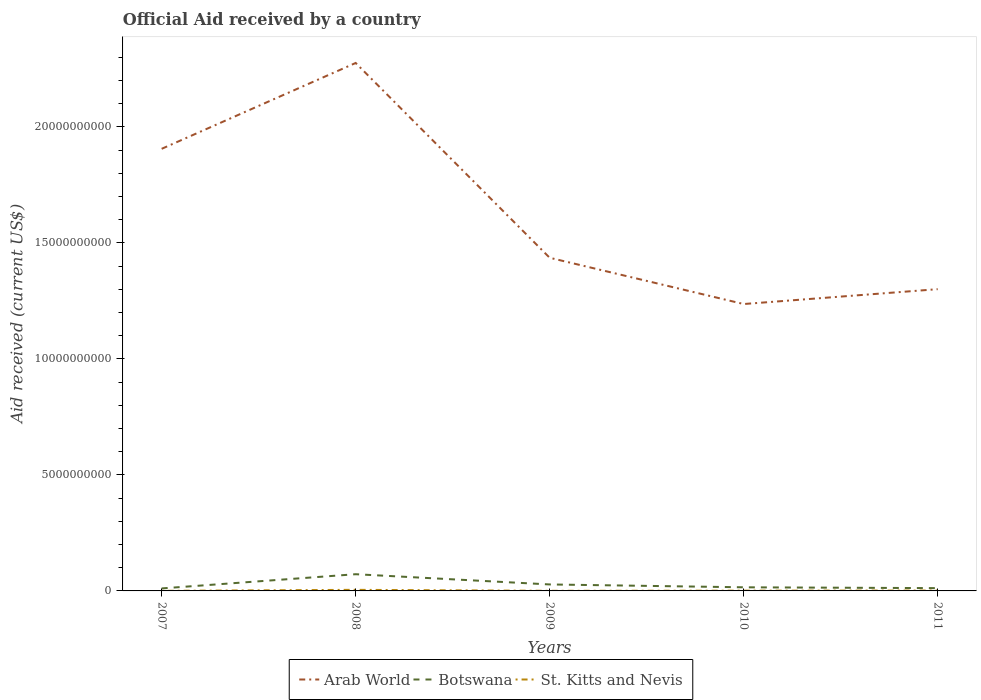How many different coloured lines are there?
Ensure brevity in your answer.  3. Does the line corresponding to St. Kitts and Nevis intersect with the line corresponding to Arab World?
Your answer should be very brief. No. Across all years, what is the maximum net official aid received in St. Kitts and Nevis?
Ensure brevity in your answer.  3.44e+06. What is the total net official aid received in Arab World in the graph?
Ensure brevity in your answer.  1.04e+1. What is the difference between the highest and the second highest net official aid received in Botswana?
Offer a very short reply. 6.13e+08. What is the difference between the highest and the lowest net official aid received in Arab World?
Make the answer very short. 2. How many lines are there?
Your response must be concise. 3. How many years are there in the graph?
Your answer should be compact. 5. Does the graph contain any zero values?
Offer a very short reply. No. How many legend labels are there?
Provide a succinct answer. 3. What is the title of the graph?
Make the answer very short. Official Aid received by a country. What is the label or title of the X-axis?
Keep it short and to the point. Years. What is the label or title of the Y-axis?
Keep it short and to the point. Aid received (current US$). What is the Aid received (current US$) in Arab World in 2007?
Your answer should be very brief. 1.91e+1. What is the Aid received (current US$) in Botswana in 2007?
Offer a very short reply. 1.08e+08. What is the Aid received (current US$) in St. Kitts and Nevis in 2007?
Provide a short and direct response. 3.44e+06. What is the Aid received (current US$) of Arab World in 2008?
Offer a terse response. 2.28e+1. What is the Aid received (current US$) of Botswana in 2008?
Your answer should be very brief. 7.20e+08. What is the Aid received (current US$) of St. Kitts and Nevis in 2008?
Your response must be concise. 4.68e+07. What is the Aid received (current US$) of Arab World in 2009?
Provide a short and direct response. 1.44e+1. What is the Aid received (current US$) in Botswana in 2009?
Your answer should be very brief. 2.79e+08. What is the Aid received (current US$) of St. Kitts and Nevis in 2009?
Make the answer very short. 5.13e+06. What is the Aid received (current US$) of Arab World in 2010?
Keep it short and to the point. 1.24e+1. What is the Aid received (current US$) in Botswana in 2010?
Give a very brief answer. 1.56e+08. What is the Aid received (current US$) in St. Kitts and Nevis in 2010?
Provide a short and direct response. 1.14e+07. What is the Aid received (current US$) in Arab World in 2011?
Offer a very short reply. 1.30e+1. What is the Aid received (current US$) of Botswana in 2011?
Make the answer very short. 1.20e+08. What is the Aid received (current US$) in St. Kitts and Nevis in 2011?
Offer a very short reply. 1.60e+07. Across all years, what is the maximum Aid received (current US$) of Arab World?
Provide a short and direct response. 2.28e+1. Across all years, what is the maximum Aid received (current US$) of Botswana?
Your answer should be compact. 7.20e+08. Across all years, what is the maximum Aid received (current US$) of St. Kitts and Nevis?
Your answer should be very brief. 4.68e+07. Across all years, what is the minimum Aid received (current US$) in Arab World?
Provide a short and direct response. 1.24e+1. Across all years, what is the minimum Aid received (current US$) in Botswana?
Provide a succinct answer. 1.08e+08. Across all years, what is the minimum Aid received (current US$) in St. Kitts and Nevis?
Make the answer very short. 3.44e+06. What is the total Aid received (current US$) of Arab World in the graph?
Give a very brief answer. 8.16e+1. What is the total Aid received (current US$) of Botswana in the graph?
Make the answer very short. 1.38e+09. What is the total Aid received (current US$) in St. Kitts and Nevis in the graph?
Keep it short and to the point. 8.28e+07. What is the difference between the Aid received (current US$) of Arab World in 2007 and that in 2008?
Offer a terse response. -3.70e+09. What is the difference between the Aid received (current US$) of Botswana in 2007 and that in 2008?
Offer a very short reply. -6.13e+08. What is the difference between the Aid received (current US$) in St. Kitts and Nevis in 2007 and that in 2008?
Keep it short and to the point. -4.34e+07. What is the difference between the Aid received (current US$) in Arab World in 2007 and that in 2009?
Provide a short and direct response. 4.70e+09. What is the difference between the Aid received (current US$) in Botswana in 2007 and that in 2009?
Offer a terse response. -1.71e+08. What is the difference between the Aid received (current US$) in St. Kitts and Nevis in 2007 and that in 2009?
Your answer should be compact. -1.69e+06. What is the difference between the Aid received (current US$) in Arab World in 2007 and that in 2010?
Offer a terse response. 6.69e+09. What is the difference between the Aid received (current US$) of Botswana in 2007 and that in 2010?
Make the answer very short. -4.85e+07. What is the difference between the Aid received (current US$) in St. Kitts and Nevis in 2007 and that in 2010?
Your answer should be compact. -7.98e+06. What is the difference between the Aid received (current US$) in Arab World in 2007 and that in 2011?
Your answer should be very brief. 6.05e+09. What is the difference between the Aid received (current US$) of Botswana in 2007 and that in 2011?
Give a very brief answer. -1.25e+07. What is the difference between the Aid received (current US$) in St. Kitts and Nevis in 2007 and that in 2011?
Provide a short and direct response. -1.26e+07. What is the difference between the Aid received (current US$) of Arab World in 2008 and that in 2009?
Your response must be concise. 8.40e+09. What is the difference between the Aid received (current US$) in Botswana in 2008 and that in 2009?
Your answer should be very brief. 4.41e+08. What is the difference between the Aid received (current US$) in St. Kitts and Nevis in 2008 and that in 2009?
Offer a terse response. 4.17e+07. What is the difference between the Aid received (current US$) of Arab World in 2008 and that in 2010?
Your response must be concise. 1.04e+1. What is the difference between the Aid received (current US$) in Botswana in 2008 and that in 2010?
Your answer should be very brief. 5.64e+08. What is the difference between the Aid received (current US$) of St. Kitts and Nevis in 2008 and that in 2010?
Provide a succinct answer. 3.54e+07. What is the difference between the Aid received (current US$) of Arab World in 2008 and that in 2011?
Your answer should be compact. 9.75e+09. What is the difference between the Aid received (current US$) in Botswana in 2008 and that in 2011?
Provide a succinct answer. 6.00e+08. What is the difference between the Aid received (current US$) of St. Kitts and Nevis in 2008 and that in 2011?
Ensure brevity in your answer.  3.08e+07. What is the difference between the Aid received (current US$) in Arab World in 2009 and that in 2010?
Your answer should be compact. 1.99e+09. What is the difference between the Aid received (current US$) of Botswana in 2009 and that in 2010?
Provide a short and direct response. 1.23e+08. What is the difference between the Aid received (current US$) of St. Kitts and Nevis in 2009 and that in 2010?
Offer a very short reply. -6.29e+06. What is the difference between the Aid received (current US$) of Arab World in 2009 and that in 2011?
Offer a terse response. 1.35e+09. What is the difference between the Aid received (current US$) in Botswana in 2009 and that in 2011?
Ensure brevity in your answer.  1.59e+08. What is the difference between the Aid received (current US$) in St. Kitts and Nevis in 2009 and that in 2011?
Your answer should be very brief. -1.09e+07. What is the difference between the Aid received (current US$) in Arab World in 2010 and that in 2011?
Provide a short and direct response. -6.41e+08. What is the difference between the Aid received (current US$) in Botswana in 2010 and that in 2011?
Provide a short and direct response. 3.60e+07. What is the difference between the Aid received (current US$) of St. Kitts and Nevis in 2010 and that in 2011?
Offer a very short reply. -4.63e+06. What is the difference between the Aid received (current US$) of Arab World in 2007 and the Aid received (current US$) of Botswana in 2008?
Make the answer very short. 1.83e+1. What is the difference between the Aid received (current US$) of Arab World in 2007 and the Aid received (current US$) of St. Kitts and Nevis in 2008?
Your answer should be very brief. 1.90e+1. What is the difference between the Aid received (current US$) of Botswana in 2007 and the Aid received (current US$) of St. Kitts and Nevis in 2008?
Keep it short and to the point. 6.09e+07. What is the difference between the Aid received (current US$) of Arab World in 2007 and the Aid received (current US$) of Botswana in 2009?
Make the answer very short. 1.88e+1. What is the difference between the Aid received (current US$) in Arab World in 2007 and the Aid received (current US$) in St. Kitts and Nevis in 2009?
Offer a terse response. 1.91e+1. What is the difference between the Aid received (current US$) of Botswana in 2007 and the Aid received (current US$) of St. Kitts and Nevis in 2009?
Keep it short and to the point. 1.03e+08. What is the difference between the Aid received (current US$) in Arab World in 2007 and the Aid received (current US$) in Botswana in 2010?
Make the answer very short. 1.89e+1. What is the difference between the Aid received (current US$) in Arab World in 2007 and the Aid received (current US$) in St. Kitts and Nevis in 2010?
Make the answer very short. 1.90e+1. What is the difference between the Aid received (current US$) of Botswana in 2007 and the Aid received (current US$) of St. Kitts and Nevis in 2010?
Provide a short and direct response. 9.62e+07. What is the difference between the Aid received (current US$) in Arab World in 2007 and the Aid received (current US$) in Botswana in 2011?
Ensure brevity in your answer.  1.89e+1. What is the difference between the Aid received (current US$) in Arab World in 2007 and the Aid received (current US$) in St. Kitts and Nevis in 2011?
Keep it short and to the point. 1.90e+1. What is the difference between the Aid received (current US$) in Botswana in 2007 and the Aid received (current US$) in St. Kitts and Nevis in 2011?
Offer a terse response. 9.16e+07. What is the difference between the Aid received (current US$) of Arab World in 2008 and the Aid received (current US$) of Botswana in 2009?
Give a very brief answer. 2.25e+1. What is the difference between the Aid received (current US$) in Arab World in 2008 and the Aid received (current US$) in St. Kitts and Nevis in 2009?
Make the answer very short. 2.28e+1. What is the difference between the Aid received (current US$) in Botswana in 2008 and the Aid received (current US$) in St. Kitts and Nevis in 2009?
Give a very brief answer. 7.15e+08. What is the difference between the Aid received (current US$) in Arab World in 2008 and the Aid received (current US$) in Botswana in 2010?
Offer a very short reply. 2.26e+1. What is the difference between the Aid received (current US$) in Arab World in 2008 and the Aid received (current US$) in St. Kitts and Nevis in 2010?
Give a very brief answer. 2.27e+1. What is the difference between the Aid received (current US$) in Botswana in 2008 and the Aid received (current US$) in St. Kitts and Nevis in 2010?
Your answer should be compact. 7.09e+08. What is the difference between the Aid received (current US$) of Arab World in 2008 and the Aid received (current US$) of Botswana in 2011?
Offer a terse response. 2.26e+1. What is the difference between the Aid received (current US$) of Arab World in 2008 and the Aid received (current US$) of St. Kitts and Nevis in 2011?
Make the answer very short. 2.27e+1. What is the difference between the Aid received (current US$) in Botswana in 2008 and the Aid received (current US$) in St. Kitts and Nevis in 2011?
Give a very brief answer. 7.04e+08. What is the difference between the Aid received (current US$) in Arab World in 2009 and the Aid received (current US$) in Botswana in 2010?
Your answer should be very brief. 1.42e+1. What is the difference between the Aid received (current US$) of Arab World in 2009 and the Aid received (current US$) of St. Kitts and Nevis in 2010?
Provide a succinct answer. 1.43e+1. What is the difference between the Aid received (current US$) in Botswana in 2009 and the Aid received (current US$) in St. Kitts and Nevis in 2010?
Your response must be concise. 2.68e+08. What is the difference between the Aid received (current US$) in Arab World in 2009 and the Aid received (current US$) in Botswana in 2011?
Provide a succinct answer. 1.42e+1. What is the difference between the Aid received (current US$) of Arab World in 2009 and the Aid received (current US$) of St. Kitts and Nevis in 2011?
Offer a very short reply. 1.43e+1. What is the difference between the Aid received (current US$) of Botswana in 2009 and the Aid received (current US$) of St. Kitts and Nevis in 2011?
Offer a very short reply. 2.63e+08. What is the difference between the Aid received (current US$) of Arab World in 2010 and the Aid received (current US$) of Botswana in 2011?
Make the answer very short. 1.22e+1. What is the difference between the Aid received (current US$) in Arab World in 2010 and the Aid received (current US$) in St. Kitts and Nevis in 2011?
Keep it short and to the point. 1.24e+1. What is the difference between the Aid received (current US$) in Botswana in 2010 and the Aid received (current US$) in St. Kitts and Nevis in 2011?
Make the answer very short. 1.40e+08. What is the average Aid received (current US$) of Arab World per year?
Ensure brevity in your answer.  1.63e+1. What is the average Aid received (current US$) of Botswana per year?
Provide a short and direct response. 2.77e+08. What is the average Aid received (current US$) in St. Kitts and Nevis per year?
Make the answer very short. 1.66e+07. In the year 2007, what is the difference between the Aid received (current US$) in Arab World and Aid received (current US$) in Botswana?
Your answer should be very brief. 1.90e+1. In the year 2007, what is the difference between the Aid received (current US$) in Arab World and Aid received (current US$) in St. Kitts and Nevis?
Keep it short and to the point. 1.91e+1. In the year 2007, what is the difference between the Aid received (current US$) in Botswana and Aid received (current US$) in St. Kitts and Nevis?
Your answer should be very brief. 1.04e+08. In the year 2008, what is the difference between the Aid received (current US$) of Arab World and Aid received (current US$) of Botswana?
Offer a very short reply. 2.20e+1. In the year 2008, what is the difference between the Aid received (current US$) in Arab World and Aid received (current US$) in St. Kitts and Nevis?
Your response must be concise. 2.27e+1. In the year 2008, what is the difference between the Aid received (current US$) in Botswana and Aid received (current US$) in St. Kitts and Nevis?
Your answer should be compact. 6.73e+08. In the year 2009, what is the difference between the Aid received (current US$) in Arab World and Aid received (current US$) in Botswana?
Your answer should be very brief. 1.41e+1. In the year 2009, what is the difference between the Aid received (current US$) in Arab World and Aid received (current US$) in St. Kitts and Nevis?
Make the answer very short. 1.44e+1. In the year 2009, what is the difference between the Aid received (current US$) of Botswana and Aid received (current US$) of St. Kitts and Nevis?
Provide a short and direct response. 2.74e+08. In the year 2010, what is the difference between the Aid received (current US$) in Arab World and Aid received (current US$) in Botswana?
Your answer should be very brief. 1.22e+1. In the year 2010, what is the difference between the Aid received (current US$) of Arab World and Aid received (current US$) of St. Kitts and Nevis?
Provide a short and direct response. 1.24e+1. In the year 2010, what is the difference between the Aid received (current US$) in Botswana and Aid received (current US$) in St. Kitts and Nevis?
Your response must be concise. 1.45e+08. In the year 2011, what is the difference between the Aid received (current US$) in Arab World and Aid received (current US$) in Botswana?
Your answer should be very brief. 1.29e+1. In the year 2011, what is the difference between the Aid received (current US$) in Arab World and Aid received (current US$) in St. Kitts and Nevis?
Your answer should be compact. 1.30e+1. In the year 2011, what is the difference between the Aid received (current US$) in Botswana and Aid received (current US$) in St. Kitts and Nevis?
Provide a short and direct response. 1.04e+08. What is the ratio of the Aid received (current US$) in Arab World in 2007 to that in 2008?
Your response must be concise. 0.84. What is the ratio of the Aid received (current US$) in Botswana in 2007 to that in 2008?
Keep it short and to the point. 0.15. What is the ratio of the Aid received (current US$) of St. Kitts and Nevis in 2007 to that in 2008?
Provide a short and direct response. 0.07. What is the ratio of the Aid received (current US$) of Arab World in 2007 to that in 2009?
Your answer should be compact. 1.33. What is the ratio of the Aid received (current US$) of Botswana in 2007 to that in 2009?
Provide a succinct answer. 0.39. What is the ratio of the Aid received (current US$) in St. Kitts and Nevis in 2007 to that in 2009?
Your answer should be very brief. 0.67. What is the ratio of the Aid received (current US$) in Arab World in 2007 to that in 2010?
Offer a very short reply. 1.54. What is the ratio of the Aid received (current US$) in Botswana in 2007 to that in 2010?
Provide a succinct answer. 0.69. What is the ratio of the Aid received (current US$) in St. Kitts and Nevis in 2007 to that in 2010?
Your answer should be compact. 0.3. What is the ratio of the Aid received (current US$) in Arab World in 2007 to that in 2011?
Your answer should be compact. 1.47. What is the ratio of the Aid received (current US$) of Botswana in 2007 to that in 2011?
Keep it short and to the point. 0.9. What is the ratio of the Aid received (current US$) of St. Kitts and Nevis in 2007 to that in 2011?
Offer a terse response. 0.21. What is the ratio of the Aid received (current US$) of Arab World in 2008 to that in 2009?
Your response must be concise. 1.58. What is the ratio of the Aid received (current US$) in Botswana in 2008 to that in 2009?
Your answer should be compact. 2.58. What is the ratio of the Aid received (current US$) in St. Kitts and Nevis in 2008 to that in 2009?
Provide a succinct answer. 9.12. What is the ratio of the Aid received (current US$) of Arab World in 2008 to that in 2010?
Your answer should be compact. 1.84. What is the ratio of the Aid received (current US$) of Botswana in 2008 to that in 2010?
Keep it short and to the point. 4.61. What is the ratio of the Aid received (current US$) of St. Kitts and Nevis in 2008 to that in 2010?
Ensure brevity in your answer.  4.1. What is the ratio of the Aid received (current US$) in Arab World in 2008 to that in 2011?
Make the answer very short. 1.75. What is the ratio of the Aid received (current US$) of Botswana in 2008 to that in 2011?
Keep it short and to the point. 5.99. What is the ratio of the Aid received (current US$) of St. Kitts and Nevis in 2008 to that in 2011?
Your answer should be very brief. 2.92. What is the ratio of the Aid received (current US$) of Arab World in 2009 to that in 2010?
Offer a terse response. 1.16. What is the ratio of the Aid received (current US$) of Botswana in 2009 to that in 2010?
Ensure brevity in your answer.  1.79. What is the ratio of the Aid received (current US$) of St. Kitts and Nevis in 2009 to that in 2010?
Give a very brief answer. 0.45. What is the ratio of the Aid received (current US$) of Arab World in 2009 to that in 2011?
Offer a very short reply. 1.1. What is the ratio of the Aid received (current US$) of Botswana in 2009 to that in 2011?
Offer a terse response. 2.32. What is the ratio of the Aid received (current US$) of St. Kitts and Nevis in 2009 to that in 2011?
Give a very brief answer. 0.32. What is the ratio of the Aid received (current US$) in Arab World in 2010 to that in 2011?
Offer a terse response. 0.95. What is the ratio of the Aid received (current US$) of Botswana in 2010 to that in 2011?
Your answer should be very brief. 1.3. What is the ratio of the Aid received (current US$) of St. Kitts and Nevis in 2010 to that in 2011?
Provide a succinct answer. 0.71. What is the difference between the highest and the second highest Aid received (current US$) in Arab World?
Offer a terse response. 3.70e+09. What is the difference between the highest and the second highest Aid received (current US$) of Botswana?
Give a very brief answer. 4.41e+08. What is the difference between the highest and the second highest Aid received (current US$) of St. Kitts and Nevis?
Your response must be concise. 3.08e+07. What is the difference between the highest and the lowest Aid received (current US$) of Arab World?
Provide a short and direct response. 1.04e+1. What is the difference between the highest and the lowest Aid received (current US$) of Botswana?
Offer a very short reply. 6.13e+08. What is the difference between the highest and the lowest Aid received (current US$) in St. Kitts and Nevis?
Offer a terse response. 4.34e+07. 